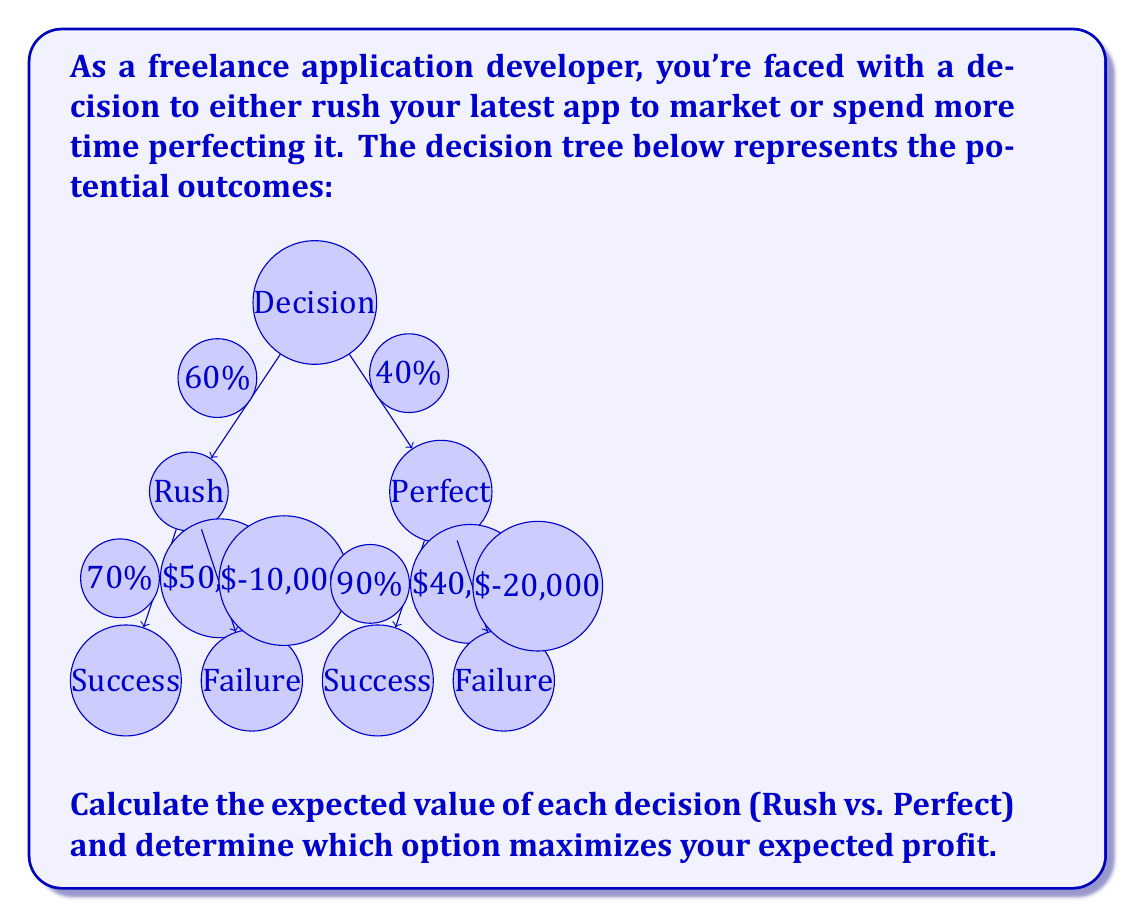Show me your answer to this math problem. To solve this problem, we need to calculate the expected value of each decision using the given probabilities and outcomes. Let's break it down step by step:

1. Expected Value for "Rush":
   a. Success: $P(\text{Success}) \times \text{Profit} = 0.70 \times \$50,000 = \$35,000$
   b. Failure: $P(\text{Failure}) \times \text{Loss} = 0.30 \times (-\$10,000) = -\$3,000$
   c. Expected Value: $\$35,000 + (-\$3,000) = \$32,000$

2. Expected Value for "Perfect":
   a. Success: $P(\text{Success}) \times \text{Profit} = 0.90 \times \$40,000 = \$36,000$
   b. Failure: $P(\text{Failure}) \times \text{Loss} = 0.10 \times (-\$20,000) = -\$2,000$
   c. Expected Value: $\$36,000 + (-\$2,000) = \$34,000$

3. Compare the expected values:
   "Rush" expected value: $\$32,000$
   "Perfect" expected value: $\$34,000$

The option that maximizes the expected profit is "Perfect" with an expected value of $\$34,000$.

This decision tree analysis shows that spending more time to perfect the app, despite the lower potential profit and higher potential loss, actually leads to a higher expected value due to the increased probability of success.
Answer: The option that maximizes expected profit is to "Perfect" the app, with an expected value of $\$34,000$. 